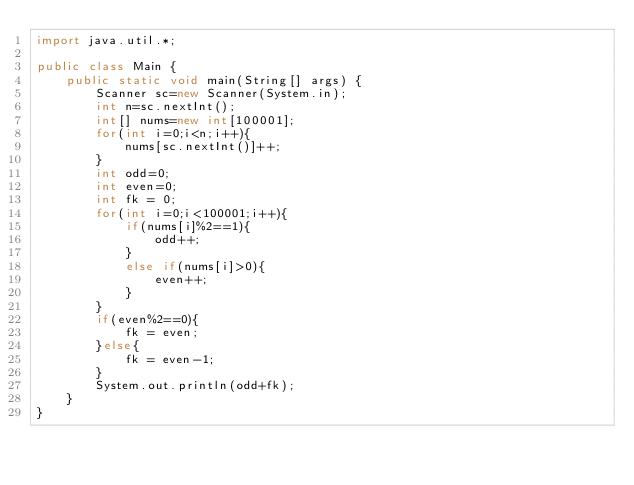<code> <loc_0><loc_0><loc_500><loc_500><_Java_>import java.util.*;

public class Main {
    public static void main(String[] args) {
        Scanner sc=new Scanner(System.in);
        int n=sc.nextInt();
        int[] nums=new int[100001];
        for(int i=0;i<n;i++){
            nums[sc.nextInt()]++;
        }
        int odd=0;
        int even=0;
        int fk = 0;
        for(int i=0;i<100001;i++){
            if(nums[i]%2==1){
            	odd++;
            }
            else if(nums[i]>0){
            	even++;
            }
        }
        if(even%2==0){
        	fk = even;
        }else{
        	fk = even-1;
        }
        System.out.println(odd+fk);
    }
}</code> 